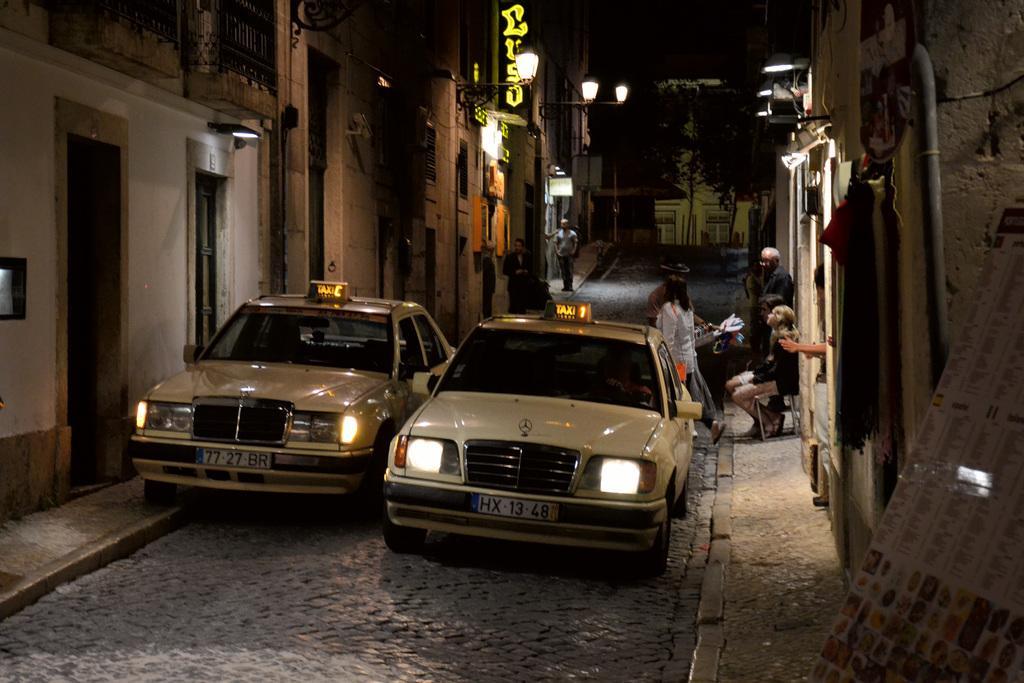In one or two sentences, can you explain what this image depicts? In the center of the image there are two cars. On the right side of the image we can see some persons are standing. On the left side of the image we can see the buildings, naming board, lights are present. On the right side of the image a board and a pipe is there. At the top of the image trees are present. At the bottom of the image road is there. 